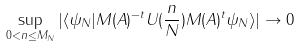<formula> <loc_0><loc_0><loc_500><loc_500>\sup _ { 0 < \| n \| \leq M _ { N } } | \langle \psi _ { N } | M ( A ) ^ { - t } U ( \frac { n } { N } ) M ( A ) ^ { t } \psi _ { N } \rangle | \to 0</formula> 